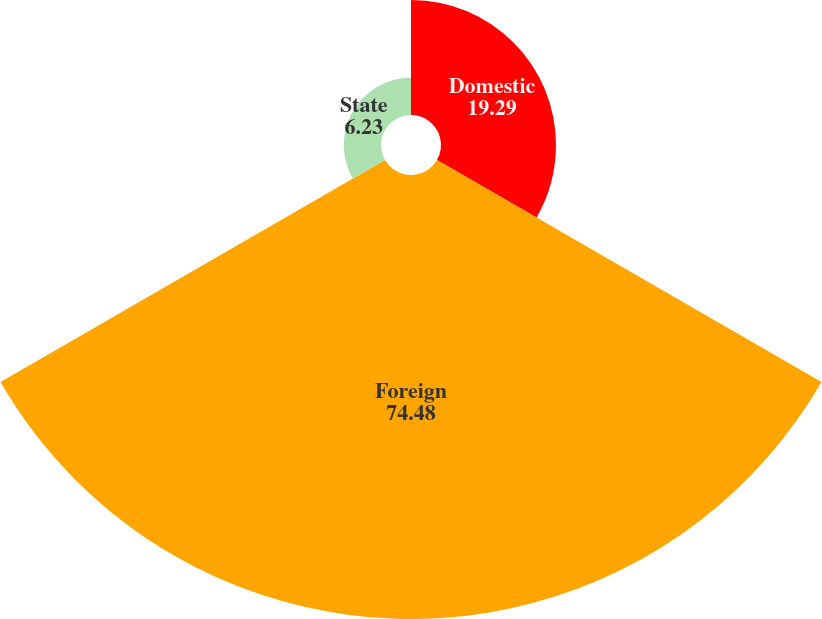Convert chart. <chart><loc_0><loc_0><loc_500><loc_500><pie_chart><fcel>Domestic<fcel>Foreign<fcel>State<nl><fcel>19.29%<fcel>74.48%<fcel>6.23%<nl></chart> 